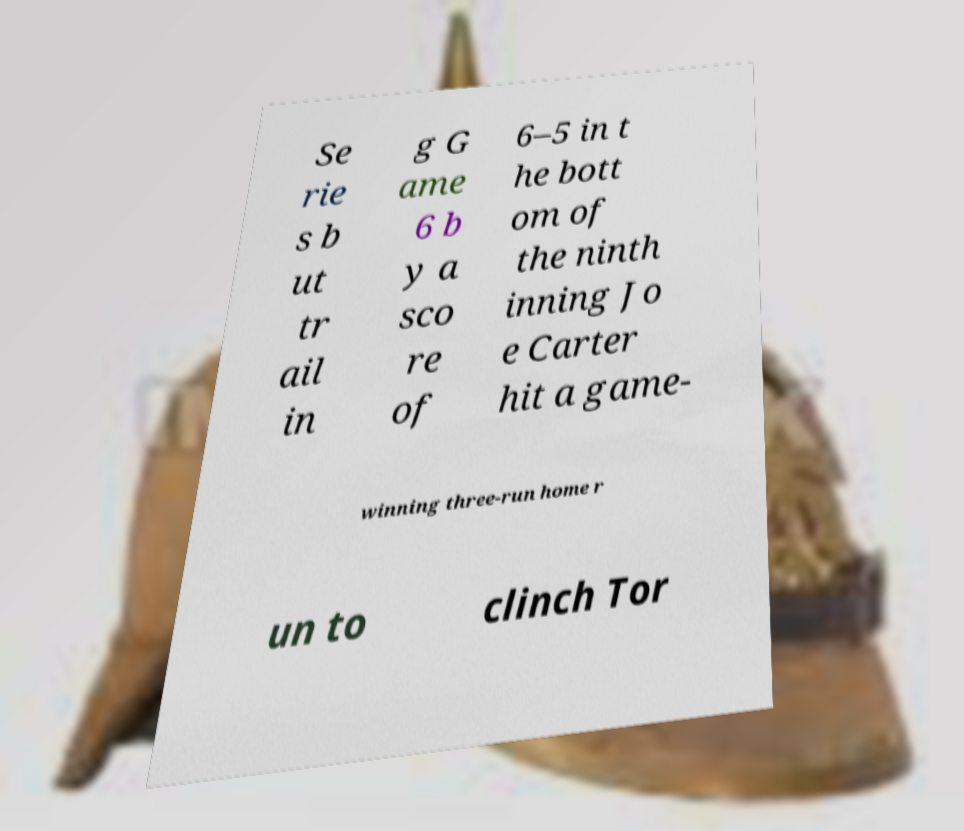Please read and relay the text visible in this image. What does it say? Se rie s b ut tr ail in g G ame 6 b y a sco re of 6–5 in t he bott om of the ninth inning Jo e Carter hit a game- winning three-run home r un to clinch Tor 